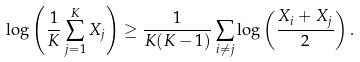<formula> <loc_0><loc_0><loc_500><loc_500>\log \left ( \frac { 1 } { K } \sum _ { j = 1 } ^ { K } X _ { j } \right ) \geq \frac { 1 } { K ( K - 1 ) } \sum _ { i \neq j } \log \left ( \frac { X _ { i } + X _ { j } } { 2 } \right ) .</formula> 